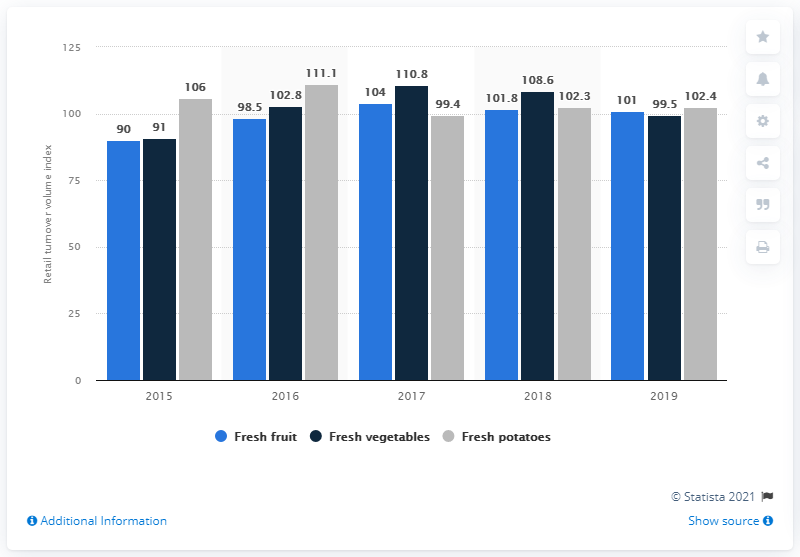Draw attention to some important aspects in this diagram. During the period of 2015-2019, a significant percentage of the sales of fresh vegetables in Russia decreased, with a specific value of 99.5%. 